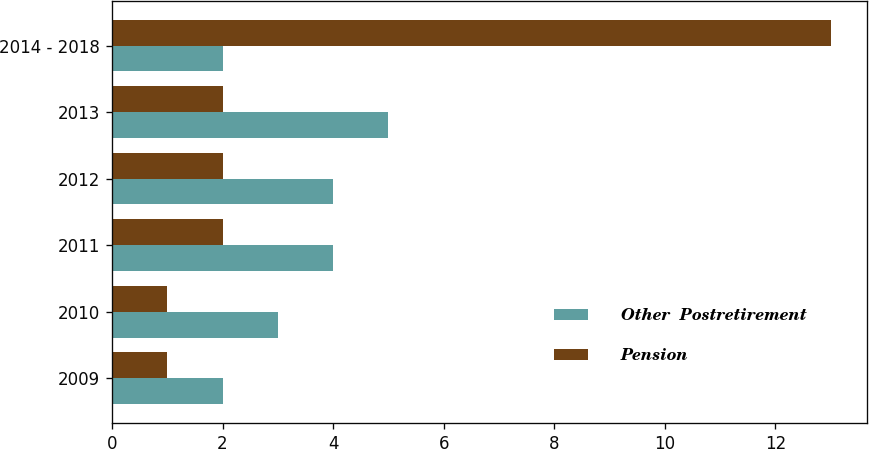Convert chart. <chart><loc_0><loc_0><loc_500><loc_500><stacked_bar_chart><ecel><fcel>2009<fcel>2010<fcel>2011<fcel>2012<fcel>2013<fcel>2014 - 2018<nl><fcel>Other  Postretirement<fcel>2<fcel>3<fcel>4<fcel>4<fcel>5<fcel>2<nl><fcel>Pension<fcel>1<fcel>1<fcel>2<fcel>2<fcel>2<fcel>13<nl></chart> 